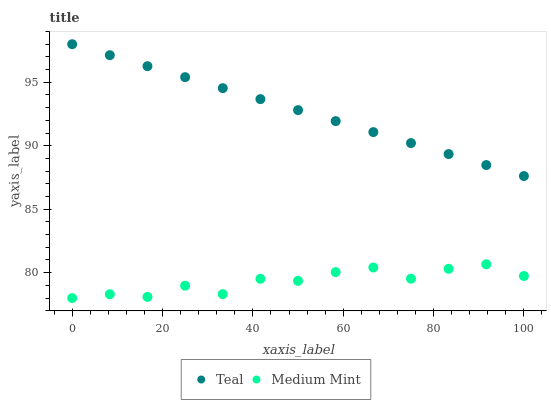Does Medium Mint have the minimum area under the curve?
Answer yes or no. Yes. Does Teal have the maximum area under the curve?
Answer yes or no. Yes. Does Teal have the minimum area under the curve?
Answer yes or no. No. Is Teal the smoothest?
Answer yes or no. Yes. Is Medium Mint the roughest?
Answer yes or no. Yes. Is Teal the roughest?
Answer yes or no. No. Does Medium Mint have the lowest value?
Answer yes or no. Yes. Does Teal have the lowest value?
Answer yes or no. No. Does Teal have the highest value?
Answer yes or no. Yes. Is Medium Mint less than Teal?
Answer yes or no. Yes. Is Teal greater than Medium Mint?
Answer yes or no. Yes. Does Medium Mint intersect Teal?
Answer yes or no. No. 